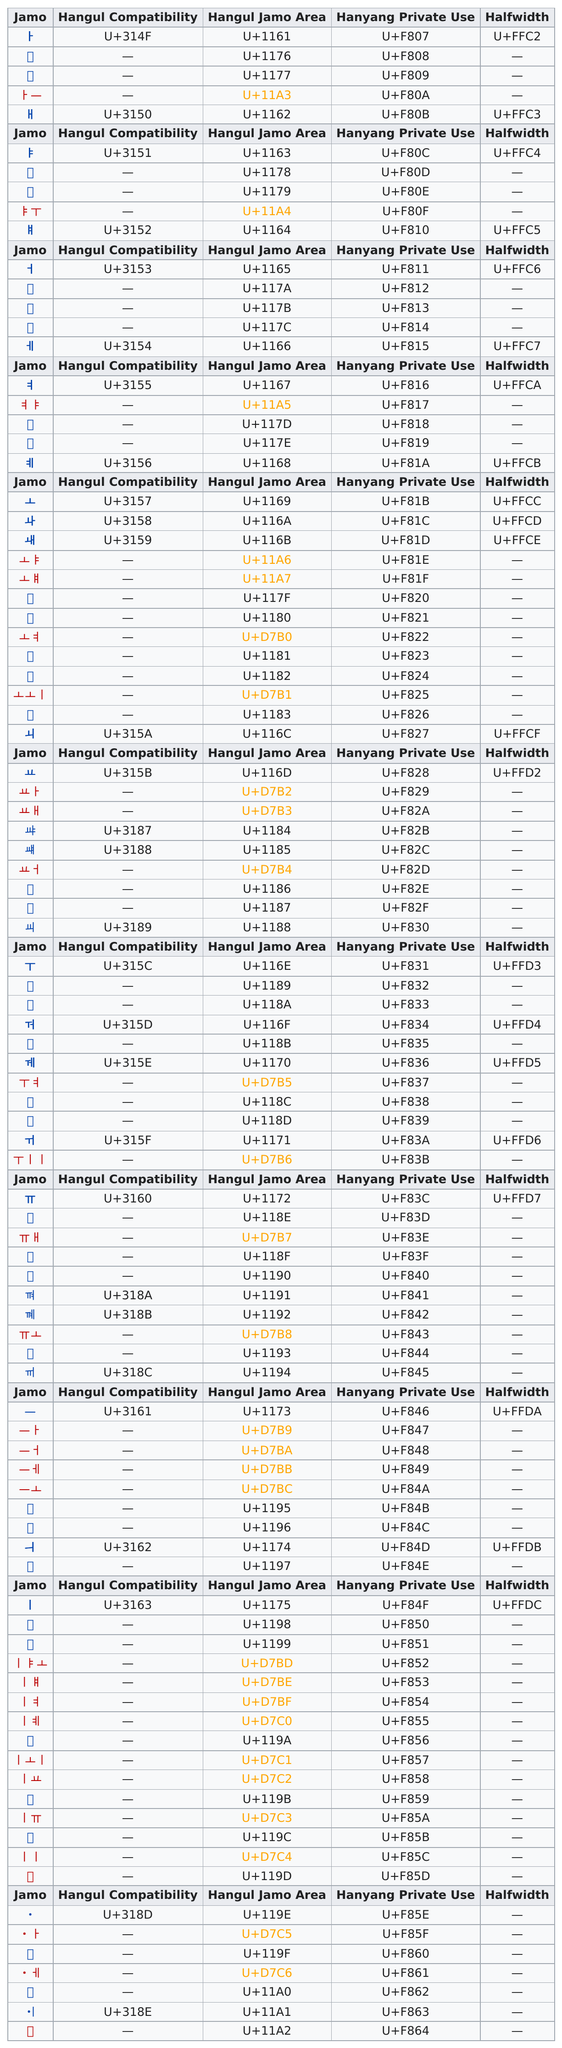Point out several critical features in this image. There are 21 halfwidth marks. The total number of times the halfwidth was recorded was 21. The symbol listed at the top of the jamo column that represents the sound of the vowel 'a' is ㅏ. 